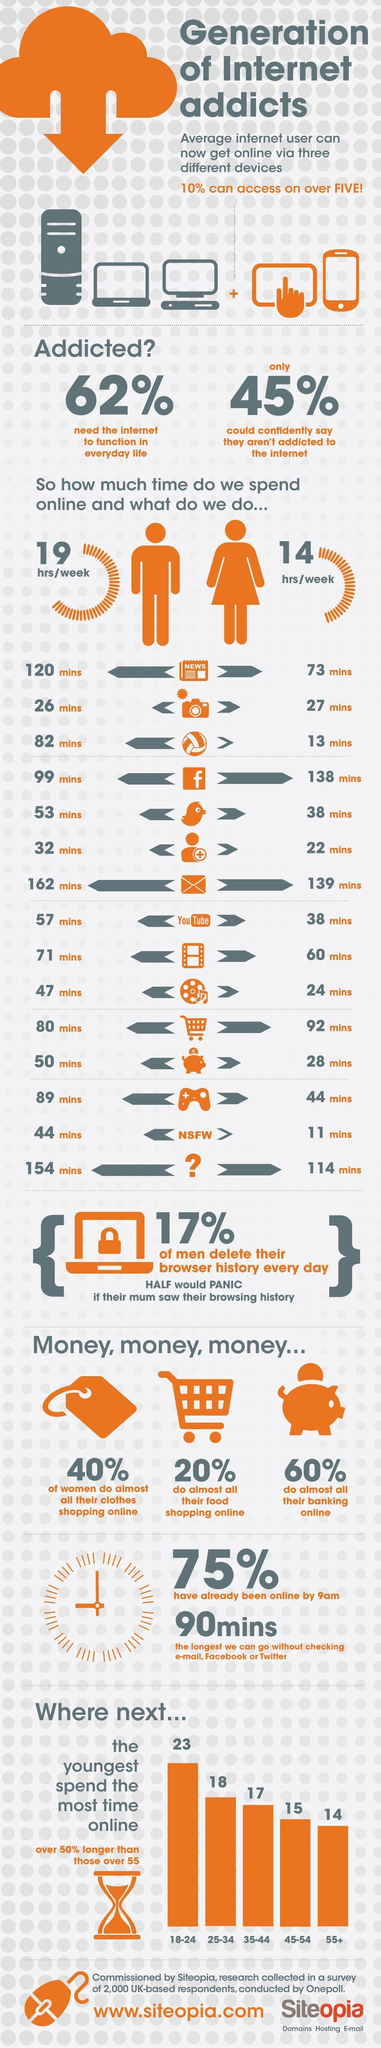How much time is spend online by males in a week?
Answer the question with a short phrase. 19 hrs/week How much time is spend by males in watching movies in a week? 71 mins How much time is spend by females in twitter per week? 38 mins What percentage of people do all their banking online? 60% How much time is spend by males in facebook per week? 99 mins How much time is spend by males in youtube per week? 57 mins How much time is spend by females in reading news per week? 73 mins How much time is spend online by females in a week? 14 hrs/week What percentage of people do almost all their food shopping online? 20% 